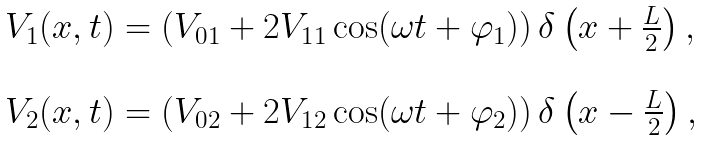<formula> <loc_0><loc_0><loc_500><loc_500>\begin{array} { l } V _ { 1 } ( x , t ) = \left ( V _ { 0 1 } + 2 V _ { 1 1 } \cos ( \omega t + \varphi _ { 1 } ) \right ) \delta \left ( x + \frac { L } { 2 } \right ) , \\ \ \\ V _ { 2 } ( x , t ) = \left ( V _ { 0 2 } + 2 V _ { 1 2 } \cos ( \omega t + \varphi _ { 2 } ) \right ) \delta \left ( x - \frac { L } { 2 } \right ) , \\ \end{array}</formula> 